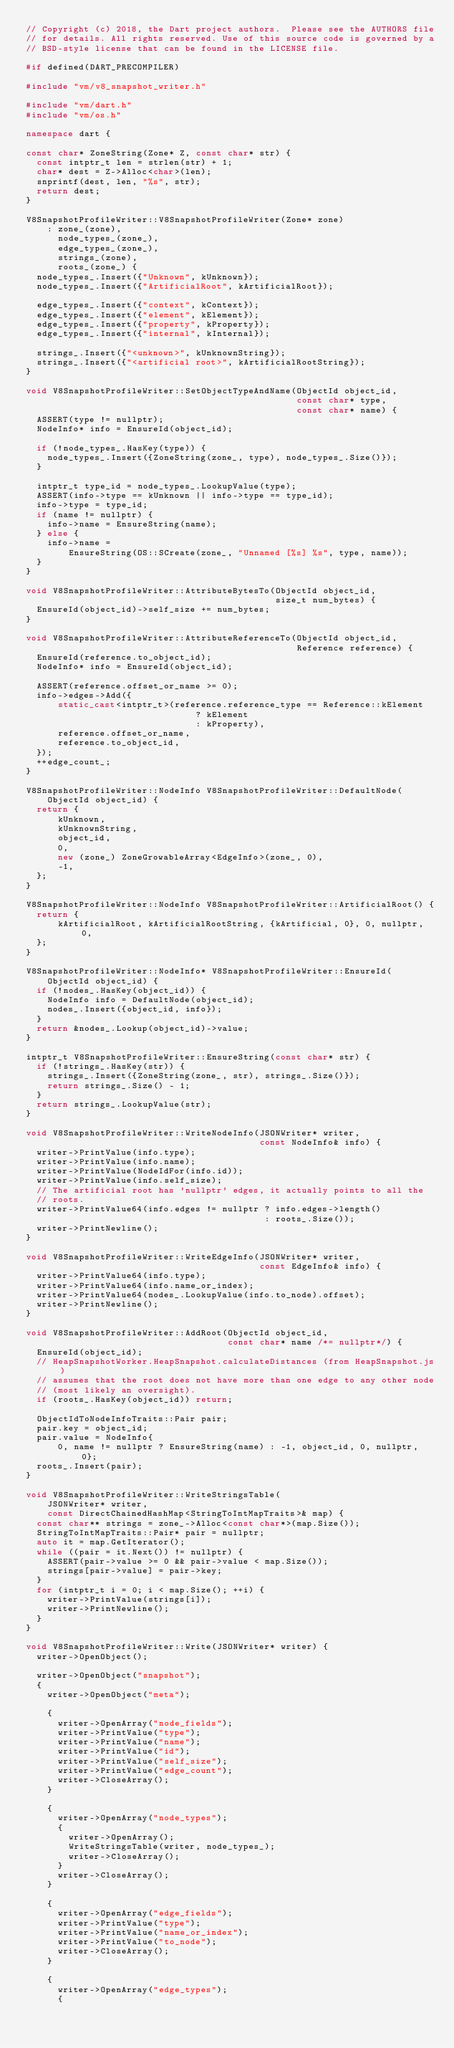<code> <loc_0><loc_0><loc_500><loc_500><_C++_>// Copyright (c) 2018, the Dart project authors.  Please see the AUTHORS file
// for details. All rights reserved. Use of this source code is governed by a
// BSD-style license that can be found in the LICENSE file.

#if defined(DART_PRECOMPILER)

#include "vm/v8_snapshot_writer.h"

#include "vm/dart.h"
#include "vm/os.h"

namespace dart {

const char* ZoneString(Zone* Z, const char* str) {
  const intptr_t len = strlen(str) + 1;
  char* dest = Z->Alloc<char>(len);
  snprintf(dest, len, "%s", str);
  return dest;
}

V8SnapshotProfileWriter::V8SnapshotProfileWriter(Zone* zone)
    : zone_(zone),
      node_types_(zone_),
      edge_types_(zone_),
      strings_(zone),
      roots_(zone_) {
  node_types_.Insert({"Unknown", kUnknown});
  node_types_.Insert({"ArtificialRoot", kArtificialRoot});

  edge_types_.Insert({"context", kContext});
  edge_types_.Insert({"element", kElement});
  edge_types_.Insert({"property", kProperty});
  edge_types_.Insert({"internal", kInternal});

  strings_.Insert({"<unknown>", kUnknownString});
  strings_.Insert({"<artificial root>", kArtificialRootString});
}

void V8SnapshotProfileWriter::SetObjectTypeAndName(ObjectId object_id,
                                                   const char* type,
                                                   const char* name) {
  ASSERT(type != nullptr);
  NodeInfo* info = EnsureId(object_id);

  if (!node_types_.HasKey(type)) {
    node_types_.Insert({ZoneString(zone_, type), node_types_.Size()});
  }

  intptr_t type_id = node_types_.LookupValue(type);
  ASSERT(info->type == kUnknown || info->type == type_id);
  info->type = type_id;
  if (name != nullptr) {
    info->name = EnsureString(name);
  } else {
    info->name =
        EnsureString(OS::SCreate(zone_, "Unnamed [%s] %s", type, name));
  }
}

void V8SnapshotProfileWriter::AttributeBytesTo(ObjectId object_id,
                                               size_t num_bytes) {
  EnsureId(object_id)->self_size += num_bytes;
}

void V8SnapshotProfileWriter::AttributeReferenceTo(ObjectId object_id,
                                                   Reference reference) {
  EnsureId(reference.to_object_id);
  NodeInfo* info = EnsureId(object_id);

  ASSERT(reference.offset_or_name >= 0);
  info->edges->Add({
      static_cast<intptr_t>(reference.reference_type == Reference::kElement
                                ? kElement
                                : kProperty),
      reference.offset_or_name,
      reference.to_object_id,
  });
  ++edge_count_;
}

V8SnapshotProfileWriter::NodeInfo V8SnapshotProfileWriter::DefaultNode(
    ObjectId object_id) {
  return {
      kUnknown,
      kUnknownString,
      object_id,
      0,
      new (zone_) ZoneGrowableArray<EdgeInfo>(zone_, 0),
      -1,
  };
}

V8SnapshotProfileWriter::NodeInfo V8SnapshotProfileWriter::ArtificialRoot() {
  return {
      kArtificialRoot, kArtificialRootString, {kArtificial, 0}, 0, nullptr, 0,
  };
}

V8SnapshotProfileWriter::NodeInfo* V8SnapshotProfileWriter::EnsureId(
    ObjectId object_id) {
  if (!nodes_.HasKey(object_id)) {
    NodeInfo info = DefaultNode(object_id);
    nodes_.Insert({object_id, info});
  }
  return &nodes_.Lookup(object_id)->value;
}

intptr_t V8SnapshotProfileWriter::EnsureString(const char* str) {
  if (!strings_.HasKey(str)) {
    strings_.Insert({ZoneString(zone_, str), strings_.Size()});
    return strings_.Size() - 1;
  }
  return strings_.LookupValue(str);
}

void V8SnapshotProfileWriter::WriteNodeInfo(JSONWriter* writer,
                                            const NodeInfo& info) {
  writer->PrintValue(info.type);
  writer->PrintValue(info.name);
  writer->PrintValue(NodeIdFor(info.id));
  writer->PrintValue(info.self_size);
  // The artificial root has 'nullptr' edges, it actually points to all the
  // roots.
  writer->PrintValue64(info.edges != nullptr ? info.edges->length()
                                             : roots_.Size());
  writer->PrintNewline();
}

void V8SnapshotProfileWriter::WriteEdgeInfo(JSONWriter* writer,
                                            const EdgeInfo& info) {
  writer->PrintValue64(info.type);
  writer->PrintValue64(info.name_or_index);
  writer->PrintValue64(nodes_.LookupValue(info.to_node).offset);
  writer->PrintNewline();
}

void V8SnapshotProfileWriter::AddRoot(ObjectId object_id,
                                      const char* name /*= nullptr*/) {
  EnsureId(object_id);
  // HeapSnapshotWorker.HeapSnapshot.calculateDistances (from HeapSnapshot.js)
  // assumes that the root does not have more than one edge to any other node
  // (most likely an oversight).
  if (roots_.HasKey(object_id)) return;

  ObjectIdToNodeInfoTraits::Pair pair;
  pair.key = object_id;
  pair.value = NodeInfo{
      0, name != nullptr ? EnsureString(name) : -1, object_id, 0, nullptr, 0};
  roots_.Insert(pair);
}

void V8SnapshotProfileWriter::WriteStringsTable(
    JSONWriter* writer,
    const DirectChainedHashMap<StringToIntMapTraits>& map) {
  const char** strings = zone_->Alloc<const char*>(map.Size());
  StringToIntMapTraits::Pair* pair = nullptr;
  auto it = map.GetIterator();
  while ((pair = it.Next()) != nullptr) {
    ASSERT(pair->value >= 0 && pair->value < map.Size());
    strings[pair->value] = pair->key;
  }
  for (intptr_t i = 0; i < map.Size(); ++i) {
    writer->PrintValue(strings[i]);
    writer->PrintNewline();
  }
}

void V8SnapshotProfileWriter::Write(JSONWriter* writer) {
  writer->OpenObject();

  writer->OpenObject("snapshot");
  {
    writer->OpenObject("meta");

    {
      writer->OpenArray("node_fields");
      writer->PrintValue("type");
      writer->PrintValue("name");
      writer->PrintValue("id");
      writer->PrintValue("self_size");
      writer->PrintValue("edge_count");
      writer->CloseArray();
    }

    {
      writer->OpenArray("node_types");
      {
        writer->OpenArray();
        WriteStringsTable(writer, node_types_);
        writer->CloseArray();
      }
      writer->CloseArray();
    }

    {
      writer->OpenArray("edge_fields");
      writer->PrintValue("type");
      writer->PrintValue("name_or_index");
      writer->PrintValue("to_node");
      writer->CloseArray();
    }

    {
      writer->OpenArray("edge_types");
      {</code> 